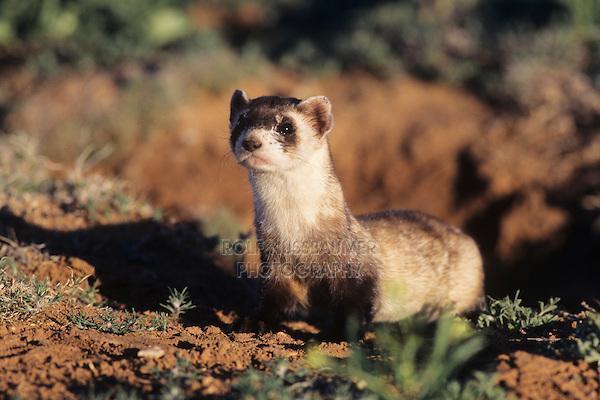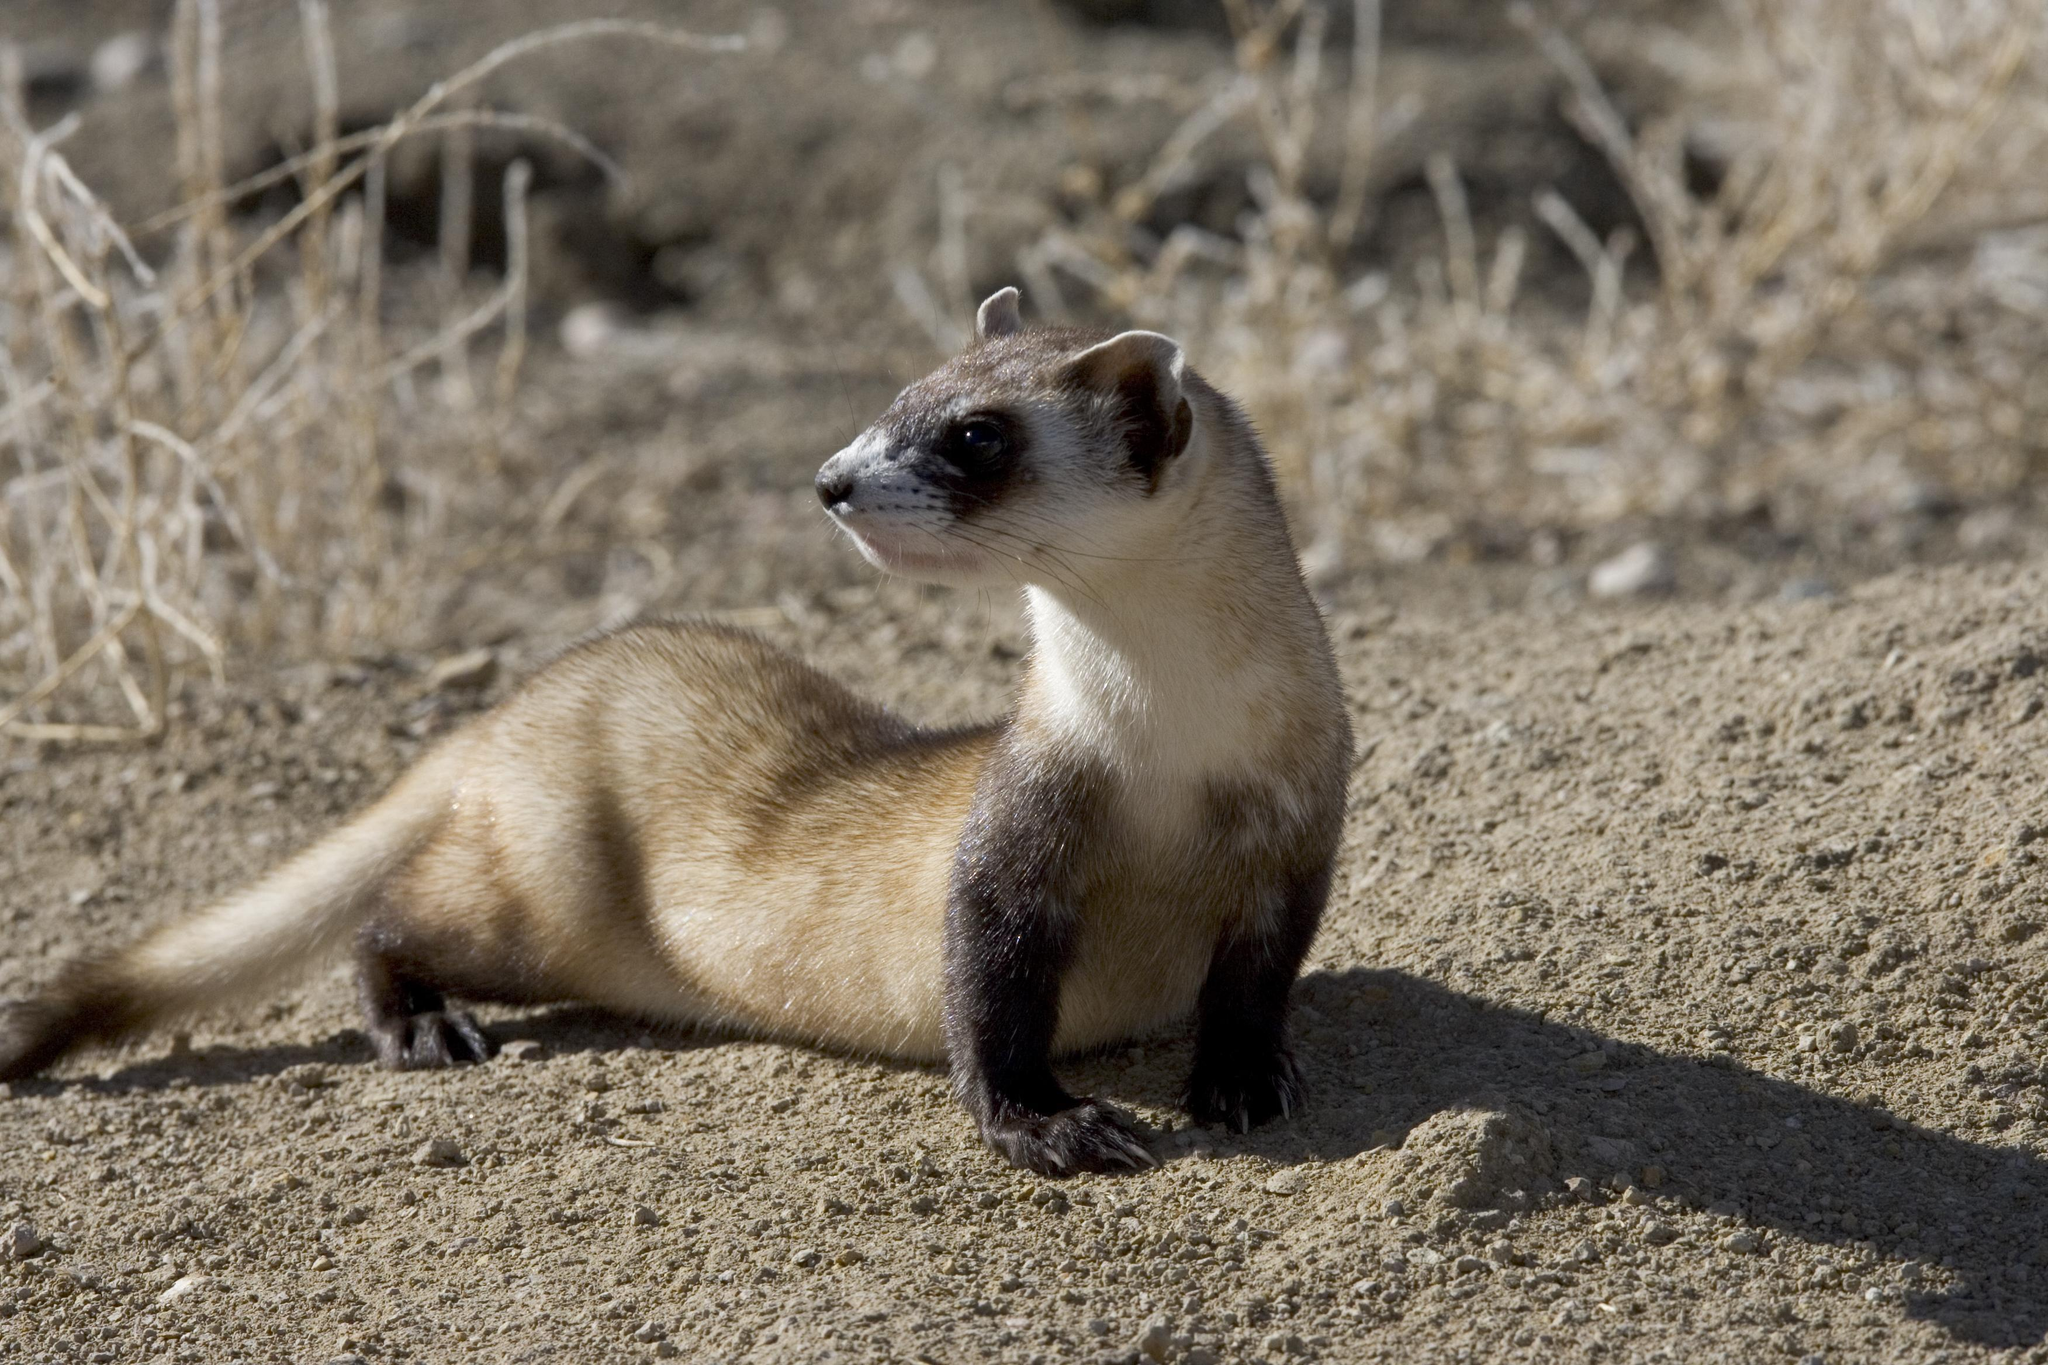The first image is the image on the left, the second image is the image on the right. Evaluate the accuracy of this statement regarding the images: "The animal in one of the images has its body turned toward the bottom left". Is it true? Answer yes or no. Yes. 